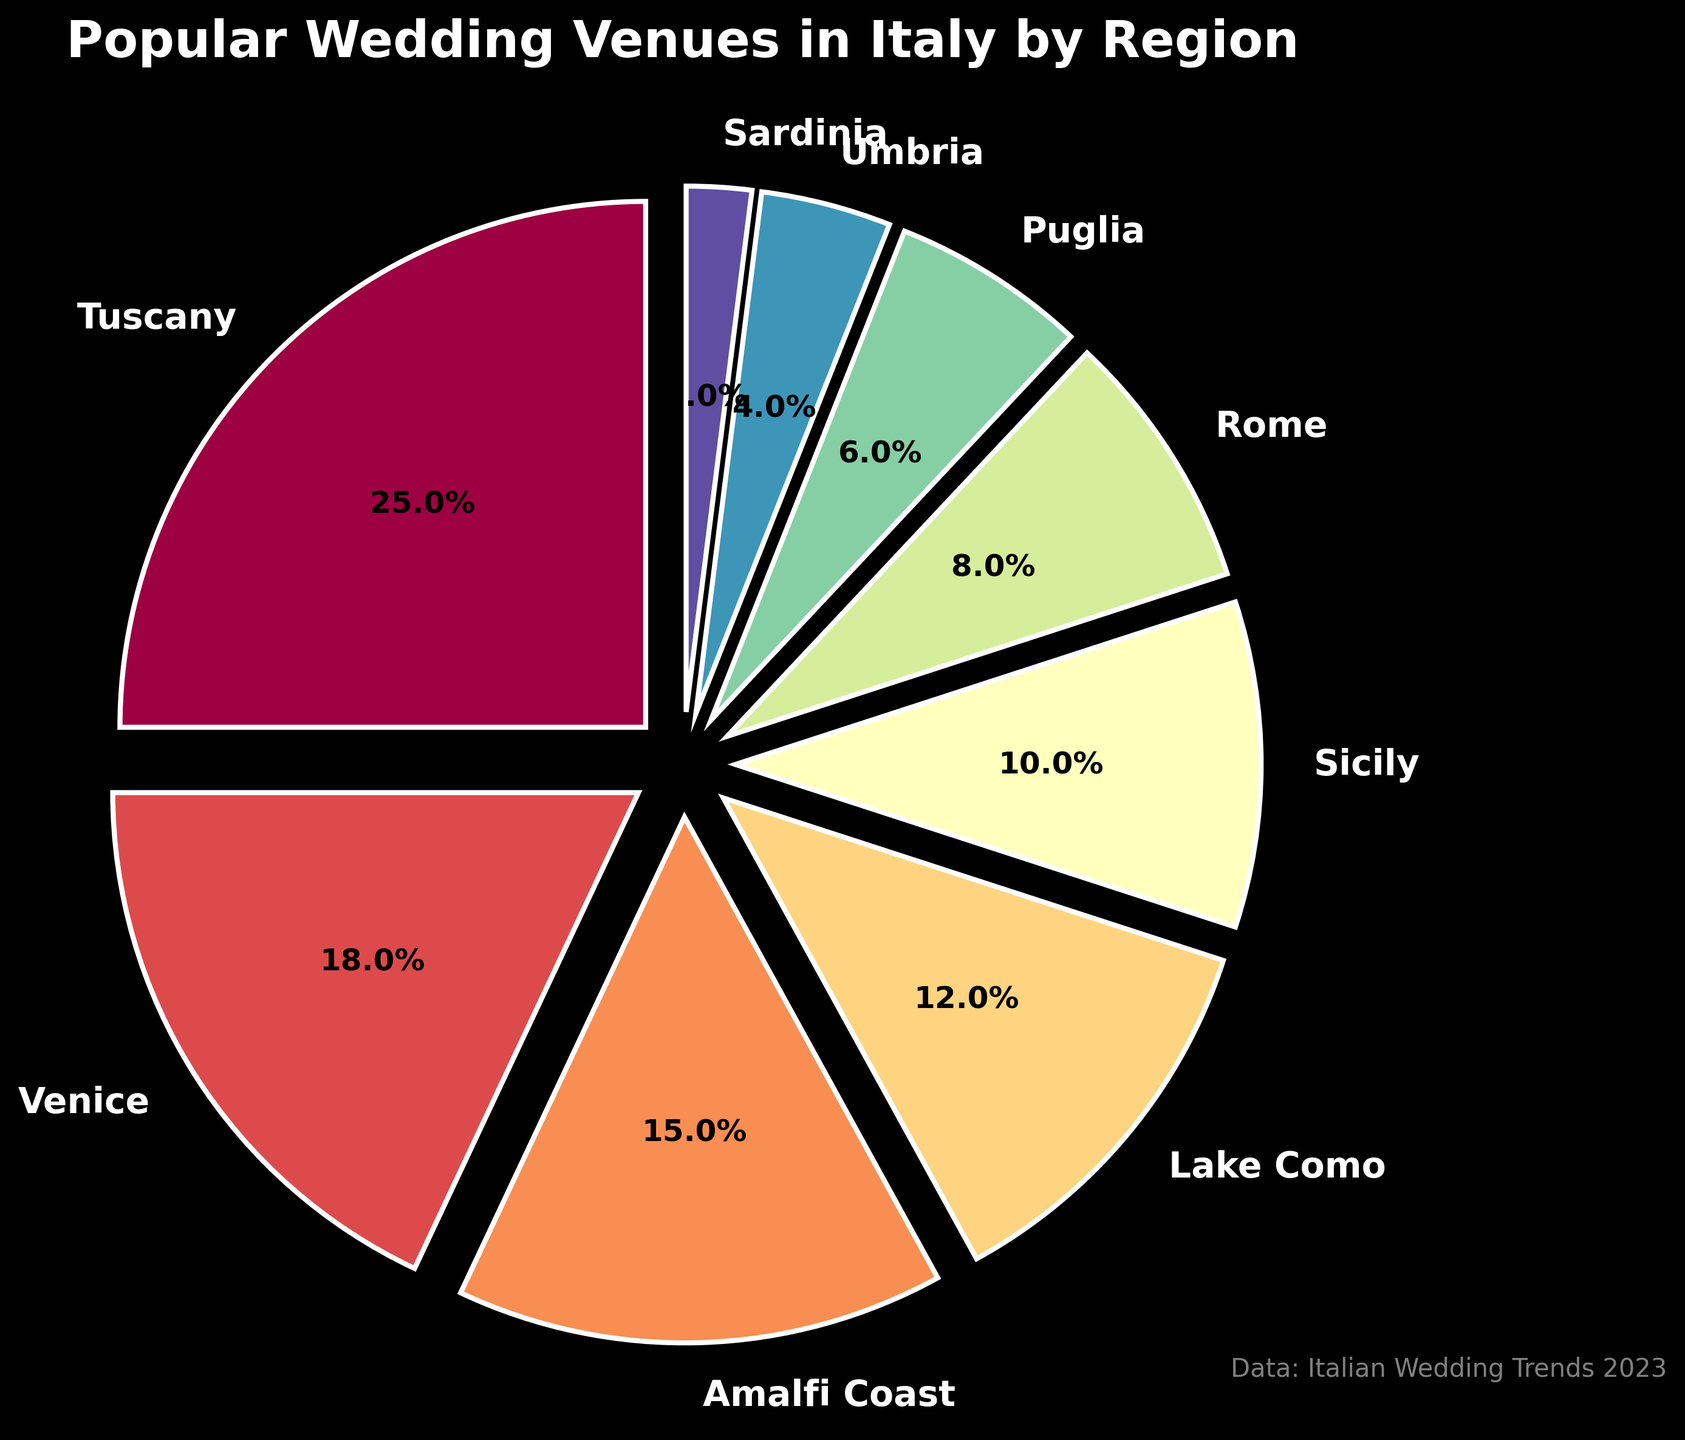Which region has the highest percentage of popular wedding venues? The region with the largest wedge and percentage label on the pie chart is Tuscany.
Answer: Tuscany Compare the percentages of Venice and Lake Como. The pie chart shows Venice at 18% and Lake Como at 12%, so Venice has a higher percentage.
Answer: Venice What is the combined percentage of Amalfi Coast and Sicily? Amalfi Coast is 15% and Sicily is 10%. Their sum is 15% + 10% = 25%.
Answer: 25% Which regions have a percentage of popular wedding venues less than 10%? The regions with percentages less than 10% are Rome (8%), Puglia (6%), Umbria (4%), and Sardinia (2%).
Answer: Rome, Puglia, Umbria, Sardinia Find the difference in percentage between the most popular region and the least popular region. Tuscany is the most popular with 25%, and Sardinia is the least popular with 2%. The difference is 25% - 2% = 23%.
Answer: 23% How much more popular is Tuscany compared to Rome? Tuscany is at 25% and Rome is at 8%. The difference is 25% - 8% = 17%.
Answer: 17% Which region is more popular, Puglia or Umbria, and by how much? Puglia is 6% and Umbria is 4%. The difference is 6% - 4% = 2%.
Answer: Puglia by 2% What is the average percentage of the regions listed in the pie chart? Add all percentages: 25 + 18 + 15 + 12 + 10 + 8 + 6 + 4 + 2 = 100. Since there are 9 regions, the average is 100 / 9 ≈ 11.11%.
Answer: 11.11% Compare the total combined percentage of Venice, Lake Como, and Amalfi Coast to Tuscany. Venice (18%) + Lake Como (12%) + Amalfi Coast (15%) = 45%. It is more than Tuscany's 25%.
Answer: Venice, Lake Como, Amalfi Coast combined Which regions have a combined percentage that equals Tuscany's percentage alone? Sicily (10%) and Venice (18%) together make 28%, which is closest to Tuscany's 25%.
Answer: Sicily and Venice 